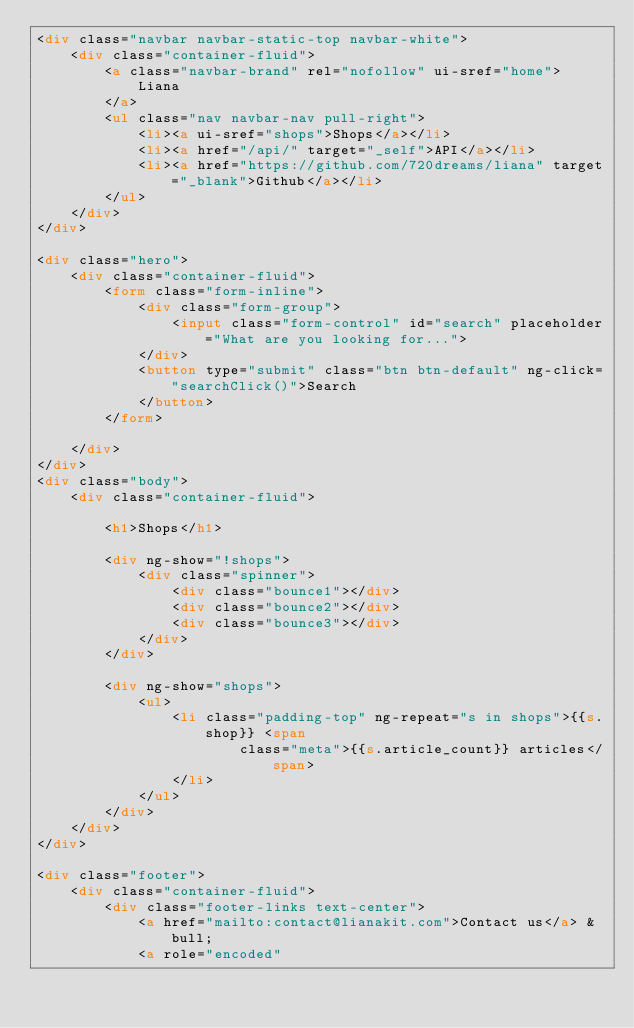<code> <loc_0><loc_0><loc_500><loc_500><_HTML_><div class="navbar navbar-static-top navbar-white">
    <div class="container-fluid">
        <a class="navbar-brand" rel="nofollow" ui-sref="home">
            Liana
        </a>
        <ul class="nav navbar-nav pull-right">
            <li><a ui-sref="shops">Shops</a></li>
            <li><a href="/api/" target="_self">API</a></li>
            <li><a href="https://github.com/720dreams/liana" target="_blank">Github</a></li>
        </ul>
    </div>
</div>

<div class="hero">
    <div class="container-fluid">
        <form class="form-inline">
            <div class="form-group">
                <input class="form-control" id="search" placeholder="What are you looking for...">
            </div>
            <button type="submit" class="btn btn-default" ng-click="searchClick()">Search
            </button>
        </form>

    </div>
</div>
<div class="body">
    <div class="container-fluid">

        <h1>Shops</h1>

        <div ng-show="!shops">
            <div class="spinner">
                <div class="bounce1"></div>
                <div class="bounce2"></div>
                <div class="bounce3"></div>
            </div>
        </div>

        <div ng-show="shops">
            <ul>
                <li class="padding-top" ng-repeat="s in shops">{{s.shop}} <span
                        class="meta">{{s.article_count}} articles</span>
                </li>
            </ul>
        </div>
    </div>
</div>

<div class="footer">
    <div class="container-fluid">
        <div class="footer-links text-center">
            <a href="mailto:contact@lianakit.com">Contact us</a> &bull;
            <a role="encoded"</code> 